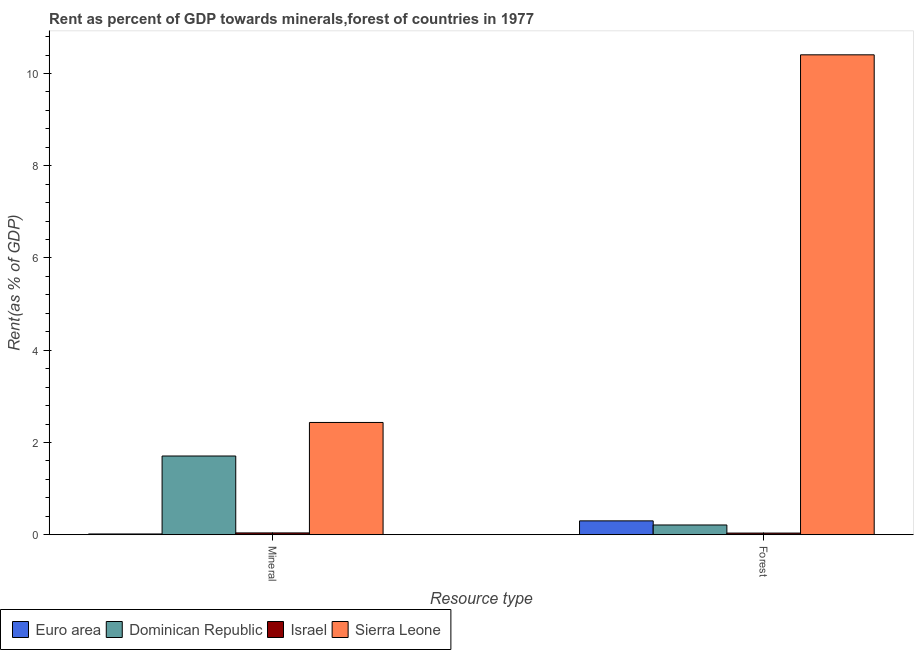How many groups of bars are there?
Give a very brief answer. 2. Are the number of bars per tick equal to the number of legend labels?
Your answer should be very brief. Yes. What is the label of the 2nd group of bars from the left?
Keep it short and to the point. Forest. What is the mineral rent in Sierra Leone?
Offer a terse response. 2.43. Across all countries, what is the maximum mineral rent?
Ensure brevity in your answer.  2.43. Across all countries, what is the minimum mineral rent?
Your response must be concise. 0.02. In which country was the mineral rent maximum?
Make the answer very short. Sierra Leone. What is the total mineral rent in the graph?
Provide a short and direct response. 4.19. What is the difference between the mineral rent in Israel and that in Dominican Republic?
Offer a very short reply. -1.67. What is the difference between the mineral rent in Dominican Republic and the forest rent in Sierra Leone?
Provide a short and direct response. -8.7. What is the average mineral rent per country?
Offer a very short reply. 1.05. What is the difference between the mineral rent and forest rent in Euro area?
Your answer should be very brief. -0.28. What is the ratio of the forest rent in Sierra Leone to that in Euro area?
Your response must be concise. 34.71. In how many countries, is the forest rent greater than the average forest rent taken over all countries?
Keep it short and to the point. 1. What does the 4th bar from the left in Forest represents?
Offer a terse response. Sierra Leone. What does the 2nd bar from the right in Mineral represents?
Provide a succinct answer. Israel. How many bars are there?
Your answer should be very brief. 8. How many countries are there in the graph?
Keep it short and to the point. 4. Are the values on the major ticks of Y-axis written in scientific E-notation?
Your answer should be compact. No. Does the graph contain grids?
Make the answer very short. No. How many legend labels are there?
Your answer should be very brief. 4. How are the legend labels stacked?
Make the answer very short. Horizontal. What is the title of the graph?
Provide a succinct answer. Rent as percent of GDP towards minerals,forest of countries in 1977. Does "Sierra Leone" appear as one of the legend labels in the graph?
Ensure brevity in your answer.  Yes. What is the label or title of the X-axis?
Provide a short and direct response. Resource type. What is the label or title of the Y-axis?
Your answer should be very brief. Rent(as % of GDP). What is the Rent(as % of GDP) of Euro area in Mineral?
Your answer should be very brief. 0.02. What is the Rent(as % of GDP) of Dominican Republic in Mineral?
Ensure brevity in your answer.  1.71. What is the Rent(as % of GDP) of Israel in Mineral?
Ensure brevity in your answer.  0.04. What is the Rent(as % of GDP) in Sierra Leone in Mineral?
Make the answer very short. 2.43. What is the Rent(as % of GDP) in Euro area in Forest?
Your answer should be compact. 0.3. What is the Rent(as % of GDP) of Dominican Republic in Forest?
Offer a very short reply. 0.21. What is the Rent(as % of GDP) in Israel in Forest?
Provide a short and direct response. 0.04. What is the Rent(as % of GDP) of Sierra Leone in Forest?
Provide a succinct answer. 10.4. Across all Resource type, what is the maximum Rent(as % of GDP) of Euro area?
Your response must be concise. 0.3. Across all Resource type, what is the maximum Rent(as % of GDP) in Dominican Republic?
Make the answer very short. 1.71. Across all Resource type, what is the maximum Rent(as % of GDP) of Israel?
Provide a short and direct response. 0.04. Across all Resource type, what is the maximum Rent(as % of GDP) of Sierra Leone?
Your response must be concise. 10.4. Across all Resource type, what is the minimum Rent(as % of GDP) in Euro area?
Ensure brevity in your answer.  0.02. Across all Resource type, what is the minimum Rent(as % of GDP) in Dominican Republic?
Give a very brief answer. 0.21. Across all Resource type, what is the minimum Rent(as % of GDP) of Israel?
Ensure brevity in your answer.  0.04. Across all Resource type, what is the minimum Rent(as % of GDP) of Sierra Leone?
Provide a short and direct response. 2.43. What is the total Rent(as % of GDP) of Euro area in the graph?
Offer a terse response. 0.32. What is the total Rent(as % of GDP) in Dominican Republic in the graph?
Give a very brief answer. 1.92. What is the total Rent(as % of GDP) in Israel in the graph?
Provide a short and direct response. 0.07. What is the total Rent(as % of GDP) in Sierra Leone in the graph?
Offer a very short reply. 12.84. What is the difference between the Rent(as % of GDP) in Euro area in Mineral and that in Forest?
Ensure brevity in your answer.  -0.28. What is the difference between the Rent(as % of GDP) of Dominican Republic in Mineral and that in Forest?
Offer a very short reply. 1.5. What is the difference between the Rent(as % of GDP) in Israel in Mineral and that in Forest?
Give a very brief answer. 0. What is the difference between the Rent(as % of GDP) of Sierra Leone in Mineral and that in Forest?
Provide a short and direct response. -7.97. What is the difference between the Rent(as % of GDP) of Euro area in Mineral and the Rent(as % of GDP) of Dominican Republic in Forest?
Keep it short and to the point. -0.19. What is the difference between the Rent(as % of GDP) of Euro area in Mineral and the Rent(as % of GDP) of Israel in Forest?
Offer a terse response. -0.02. What is the difference between the Rent(as % of GDP) of Euro area in Mineral and the Rent(as % of GDP) of Sierra Leone in Forest?
Your response must be concise. -10.39. What is the difference between the Rent(as % of GDP) in Dominican Republic in Mineral and the Rent(as % of GDP) in Israel in Forest?
Provide a short and direct response. 1.67. What is the difference between the Rent(as % of GDP) of Dominican Republic in Mineral and the Rent(as % of GDP) of Sierra Leone in Forest?
Keep it short and to the point. -8.7. What is the difference between the Rent(as % of GDP) of Israel in Mineral and the Rent(as % of GDP) of Sierra Leone in Forest?
Offer a terse response. -10.37. What is the average Rent(as % of GDP) in Euro area per Resource type?
Your response must be concise. 0.16. What is the average Rent(as % of GDP) of Dominican Republic per Resource type?
Your response must be concise. 0.96. What is the average Rent(as % of GDP) of Israel per Resource type?
Your answer should be compact. 0.04. What is the average Rent(as % of GDP) of Sierra Leone per Resource type?
Keep it short and to the point. 6.42. What is the difference between the Rent(as % of GDP) of Euro area and Rent(as % of GDP) of Dominican Republic in Mineral?
Give a very brief answer. -1.69. What is the difference between the Rent(as % of GDP) of Euro area and Rent(as % of GDP) of Israel in Mineral?
Offer a very short reply. -0.02. What is the difference between the Rent(as % of GDP) in Euro area and Rent(as % of GDP) in Sierra Leone in Mineral?
Your response must be concise. -2.42. What is the difference between the Rent(as % of GDP) of Dominican Republic and Rent(as % of GDP) of Israel in Mineral?
Your answer should be compact. 1.67. What is the difference between the Rent(as % of GDP) in Dominican Republic and Rent(as % of GDP) in Sierra Leone in Mineral?
Provide a short and direct response. -0.73. What is the difference between the Rent(as % of GDP) of Israel and Rent(as % of GDP) of Sierra Leone in Mineral?
Your response must be concise. -2.4. What is the difference between the Rent(as % of GDP) in Euro area and Rent(as % of GDP) in Dominican Republic in Forest?
Offer a very short reply. 0.09. What is the difference between the Rent(as % of GDP) in Euro area and Rent(as % of GDP) in Israel in Forest?
Offer a terse response. 0.26. What is the difference between the Rent(as % of GDP) of Euro area and Rent(as % of GDP) of Sierra Leone in Forest?
Offer a terse response. -10.11. What is the difference between the Rent(as % of GDP) of Dominican Republic and Rent(as % of GDP) of Israel in Forest?
Your answer should be very brief. 0.18. What is the difference between the Rent(as % of GDP) in Dominican Republic and Rent(as % of GDP) in Sierra Leone in Forest?
Provide a succinct answer. -10.19. What is the difference between the Rent(as % of GDP) of Israel and Rent(as % of GDP) of Sierra Leone in Forest?
Offer a very short reply. -10.37. What is the ratio of the Rent(as % of GDP) of Euro area in Mineral to that in Forest?
Your answer should be very brief. 0.05. What is the ratio of the Rent(as % of GDP) in Dominican Republic in Mineral to that in Forest?
Make the answer very short. 8.1. What is the ratio of the Rent(as % of GDP) in Israel in Mineral to that in Forest?
Keep it short and to the point. 1.1. What is the ratio of the Rent(as % of GDP) of Sierra Leone in Mineral to that in Forest?
Make the answer very short. 0.23. What is the difference between the highest and the second highest Rent(as % of GDP) of Euro area?
Your response must be concise. 0.28. What is the difference between the highest and the second highest Rent(as % of GDP) of Dominican Republic?
Keep it short and to the point. 1.5. What is the difference between the highest and the second highest Rent(as % of GDP) of Israel?
Your response must be concise. 0. What is the difference between the highest and the second highest Rent(as % of GDP) in Sierra Leone?
Make the answer very short. 7.97. What is the difference between the highest and the lowest Rent(as % of GDP) in Euro area?
Provide a short and direct response. 0.28. What is the difference between the highest and the lowest Rent(as % of GDP) of Dominican Republic?
Your answer should be compact. 1.5. What is the difference between the highest and the lowest Rent(as % of GDP) of Israel?
Your answer should be compact. 0. What is the difference between the highest and the lowest Rent(as % of GDP) of Sierra Leone?
Make the answer very short. 7.97. 